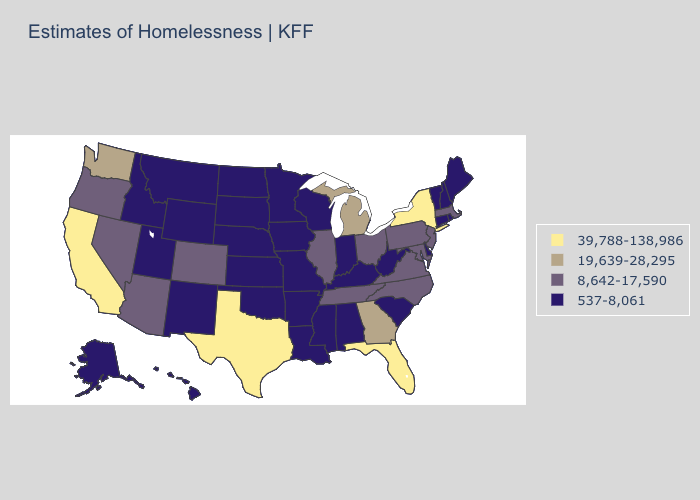What is the value of Louisiana?
Quick response, please. 537-8,061. What is the value of Minnesota?
Answer briefly. 537-8,061. Name the states that have a value in the range 39,788-138,986?
Be succinct. California, Florida, New York, Texas. Among the states that border Indiana , which have the lowest value?
Short answer required. Kentucky. Which states have the lowest value in the West?
Quick response, please. Alaska, Hawaii, Idaho, Montana, New Mexico, Utah, Wyoming. Which states hav the highest value in the South?
Be succinct. Florida, Texas. Does Georgia have the lowest value in the USA?
Be succinct. No. What is the value of Arkansas?
Be succinct. 537-8,061. Among the states that border Virginia , does West Virginia have the highest value?
Quick response, please. No. Which states have the lowest value in the South?
Give a very brief answer. Alabama, Arkansas, Delaware, Kentucky, Louisiana, Mississippi, Oklahoma, South Carolina, West Virginia. Which states hav the highest value in the South?
Concise answer only. Florida, Texas. Which states have the lowest value in the Northeast?
Short answer required. Connecticut, Maine, New Hampshire, Rhode Island, Vermont. What is the value of North Carolina?
Give a very brief answer. 8,642-17,590. What is the lowest value in states that border Georgia?
Write a very short answer. 537-8,061. Name the states that have a value in the range 19,639-28,295?
Concise answer only. Georgia, Michigan, Washington. 